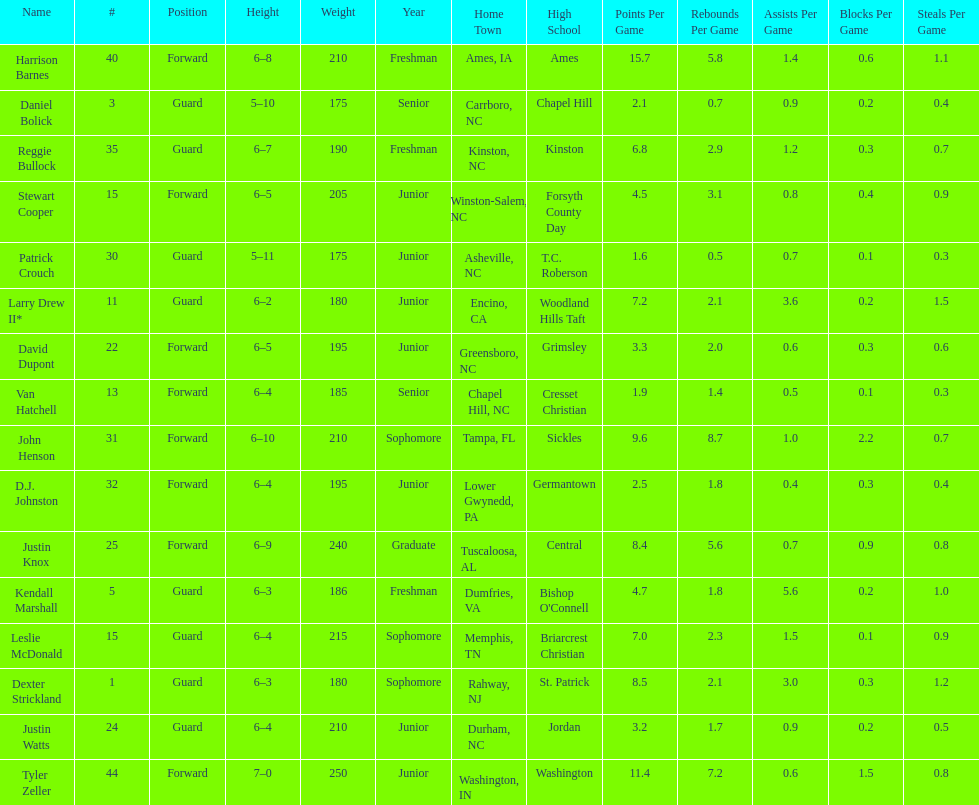Total number of players whose home town was in north carolina (nc) 7. 